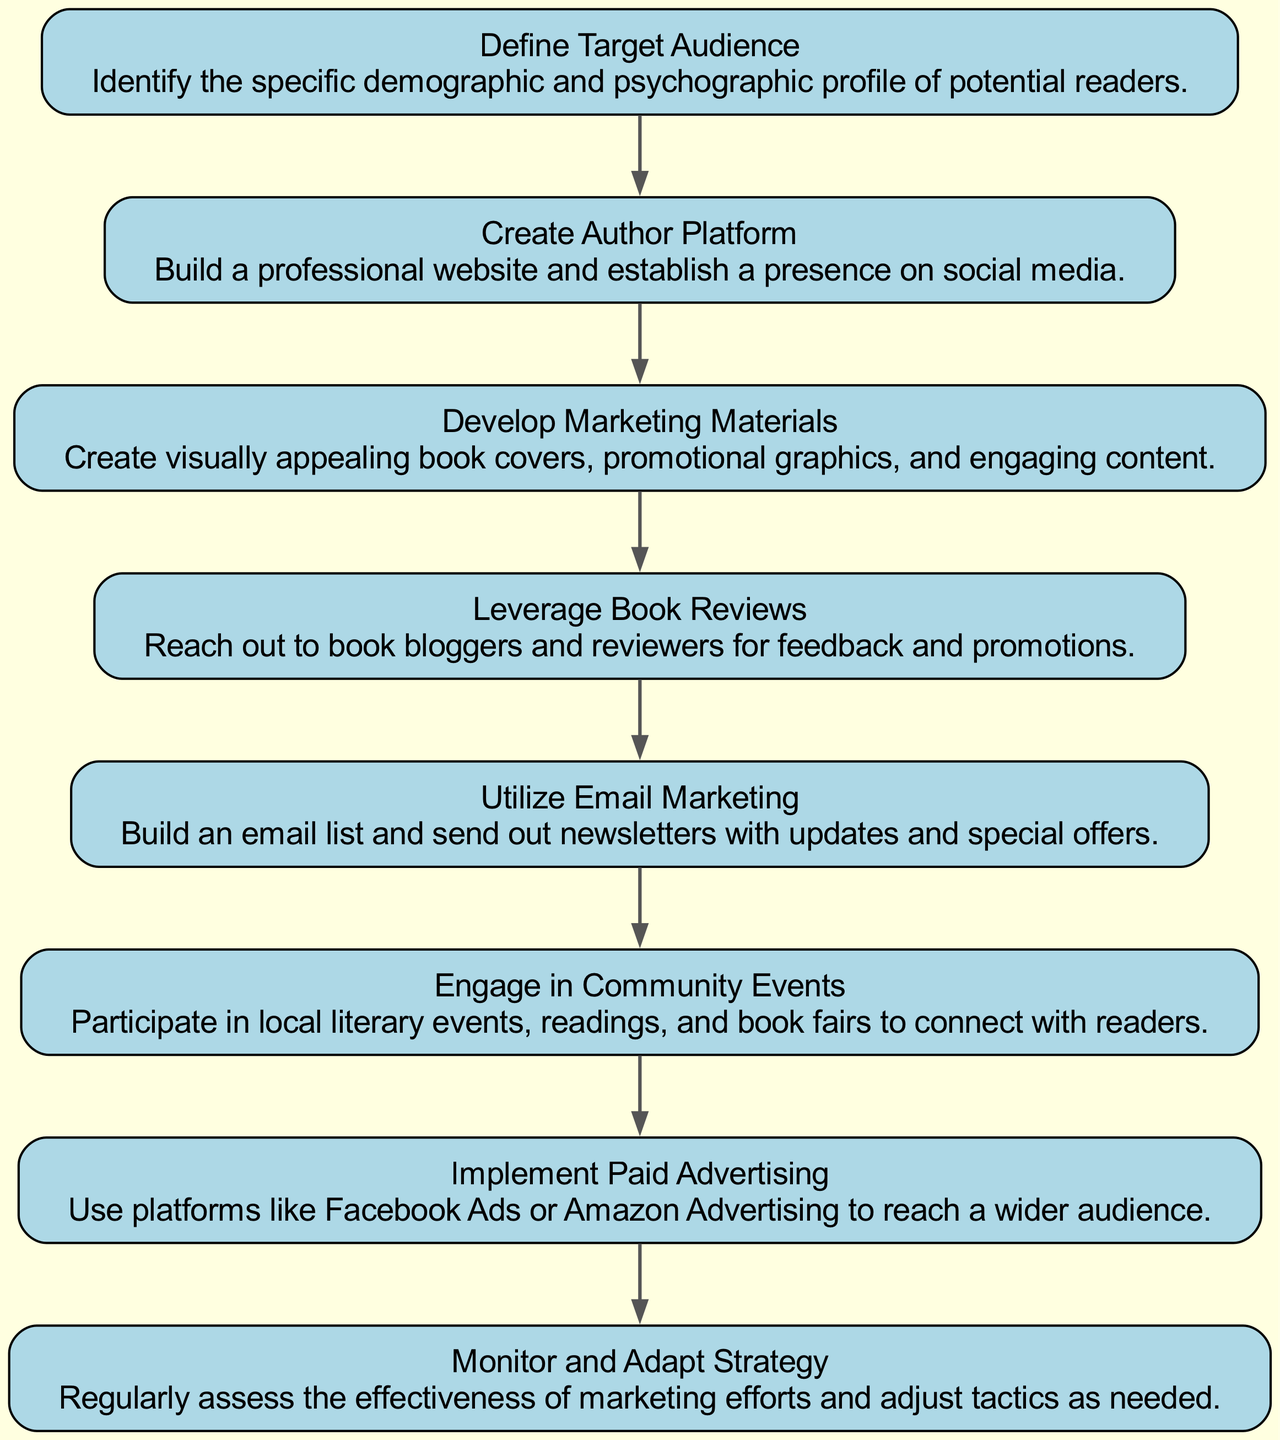What is the first step in the marketing strategy? The first step in the diagram is to "Define Target Audience." This is indicated as the topmost node in the flow chart, representing the initial action in the process.
Answer: Define Target Audience How many total nodes are present in the diagram? By counting the unique elements listed, there are eight nodes in total outlining different steps in the marketing strategy.
Answer: 8 What follows "Create Author Platform" in the flow chart? The step immediately following "Create Author Platform" is "Develop Marketing Materials," which is connected visually in the flow of the chart.
Answer: Develop Marketing Materials Which step emphasizes community engagement? "Engage in Community Events" is the specific step that focuses on connecting with readers and the local literary community, as represented by one of the nodes.
Answer: Engage in Community Events How many times does the term 'marketing' appear in the node descriptions? Upon reviewing all the node descriptions, the term 'marketing' appears three times throughout the various steps indicating different marketing tactics.
Answer: 3 What is the last step in the marketing flow? The last step depicted in the flow chart is "Monitor and Adapt Strategy," which signifies the final action taken after all previous steps have been implemented.
Answer: Monitor and Adapt Strategy Which strategies involve outreach to external parties? "Leverage Book Reviews" and "Utilize Email Marketing" both involve outreach; the former seeks feedback and promotion from reviewers, while the latter targets potential readers via newsletters.
Answer: Leverage Book Reviews, Utilize Email Marketing What type of advertising is mentioned in the diagram? The type of advertising mentioned is "Paid Advertising," indicating the focus on using paid platforms like Facebook Ads and Amazon Advertising.
Answer: Paid Advertising 